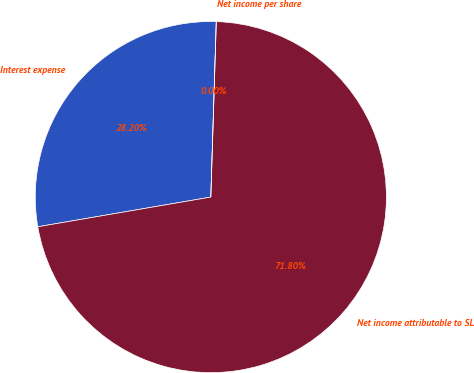Convert chart. <chart><loc_0><loc_0><loc_500><loc_500><pie_chart><fcel>Interest expense<fcel>Net income attributable to SL<fcel>Net income per share<nl><fcel>28.2%<fcel>71.8%<fcel>0.0%<nl></chart> 